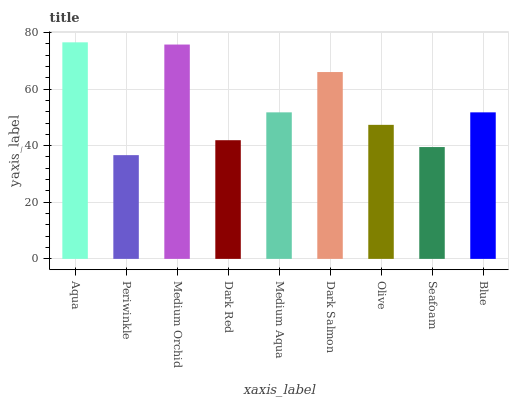Is Medium Orchid the minimum?
Answer yes or no. No. Is Medium Orchid the maximum?
Answer yes or no. No. Is Medium Orchid greater than Periwinkle?
Answer yes or no. Yes. Is Periwinkle less than Medium Orchid?
Answer yes or no. Yes. Is Periwinkle greater than Medium Orchid?
Answer yes or no. No. Is Medium Orchid less than Periwinkle?
Answer yes or no. No. Is Medium Aqua the high median?
Answer yes or no. Yes. Is Medium Aqua the low median?
Answer yes or no. Yes. Is Medium Orchid the high median?
Answer yes or no. No. Is Dark Salmon the low median?
Answer yes or no. No. 